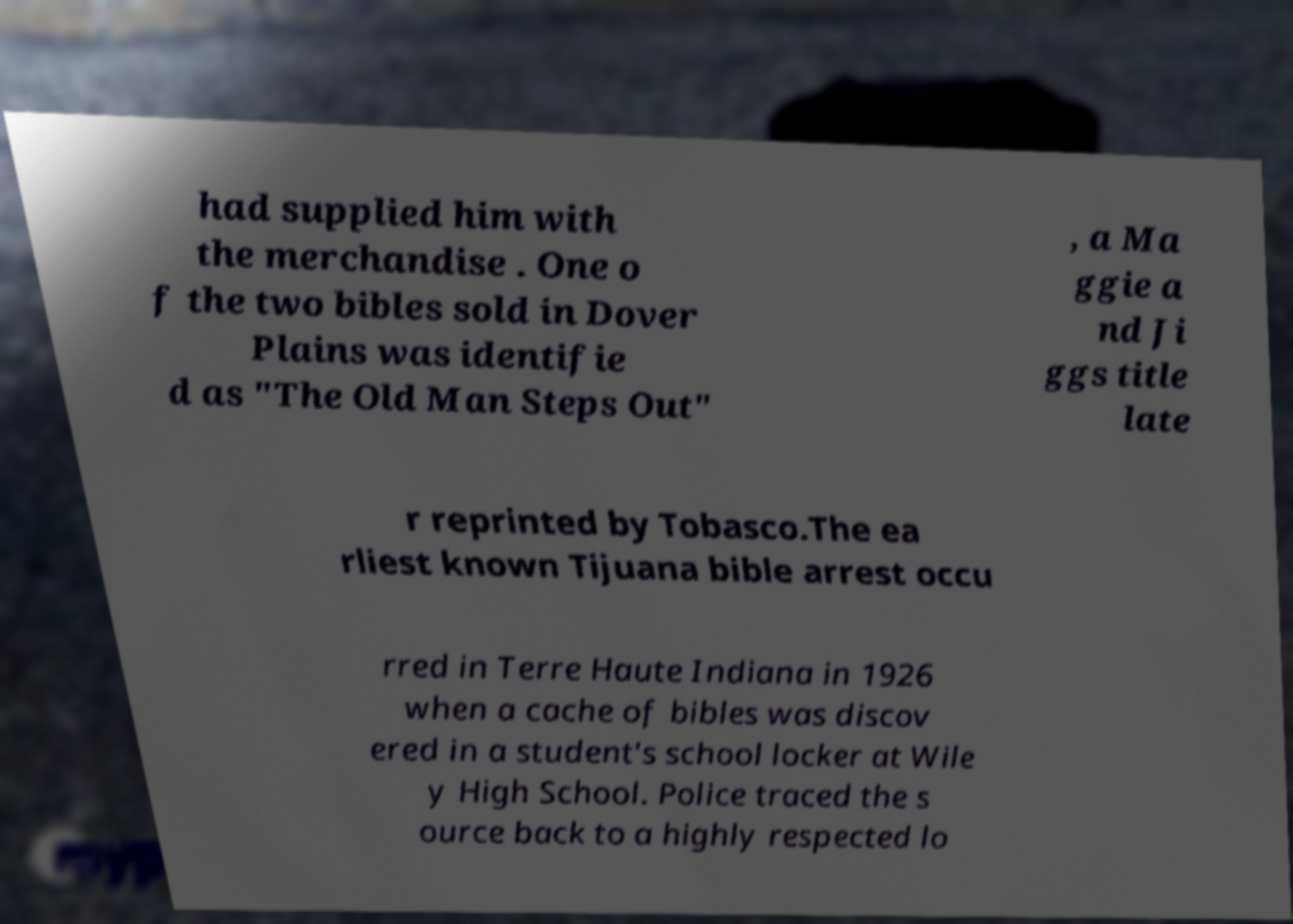Please read and relay the text visible in this image. What does it say? had supplied him with the merchandise . One o f the two bibles sold in Dover Plains was identifie d as "The Old Man Steps Out" , a Ma ggie a nd Ji ggs title late r reprinted by Tobasco.The ea rliest known Tijuana bible arrest occu rred in Terre Haute Indiana in 1926 when a cache of bibles was discov ered in a student's school locker at Wile y High School. Police traced the s ource back to a highly respected lo 